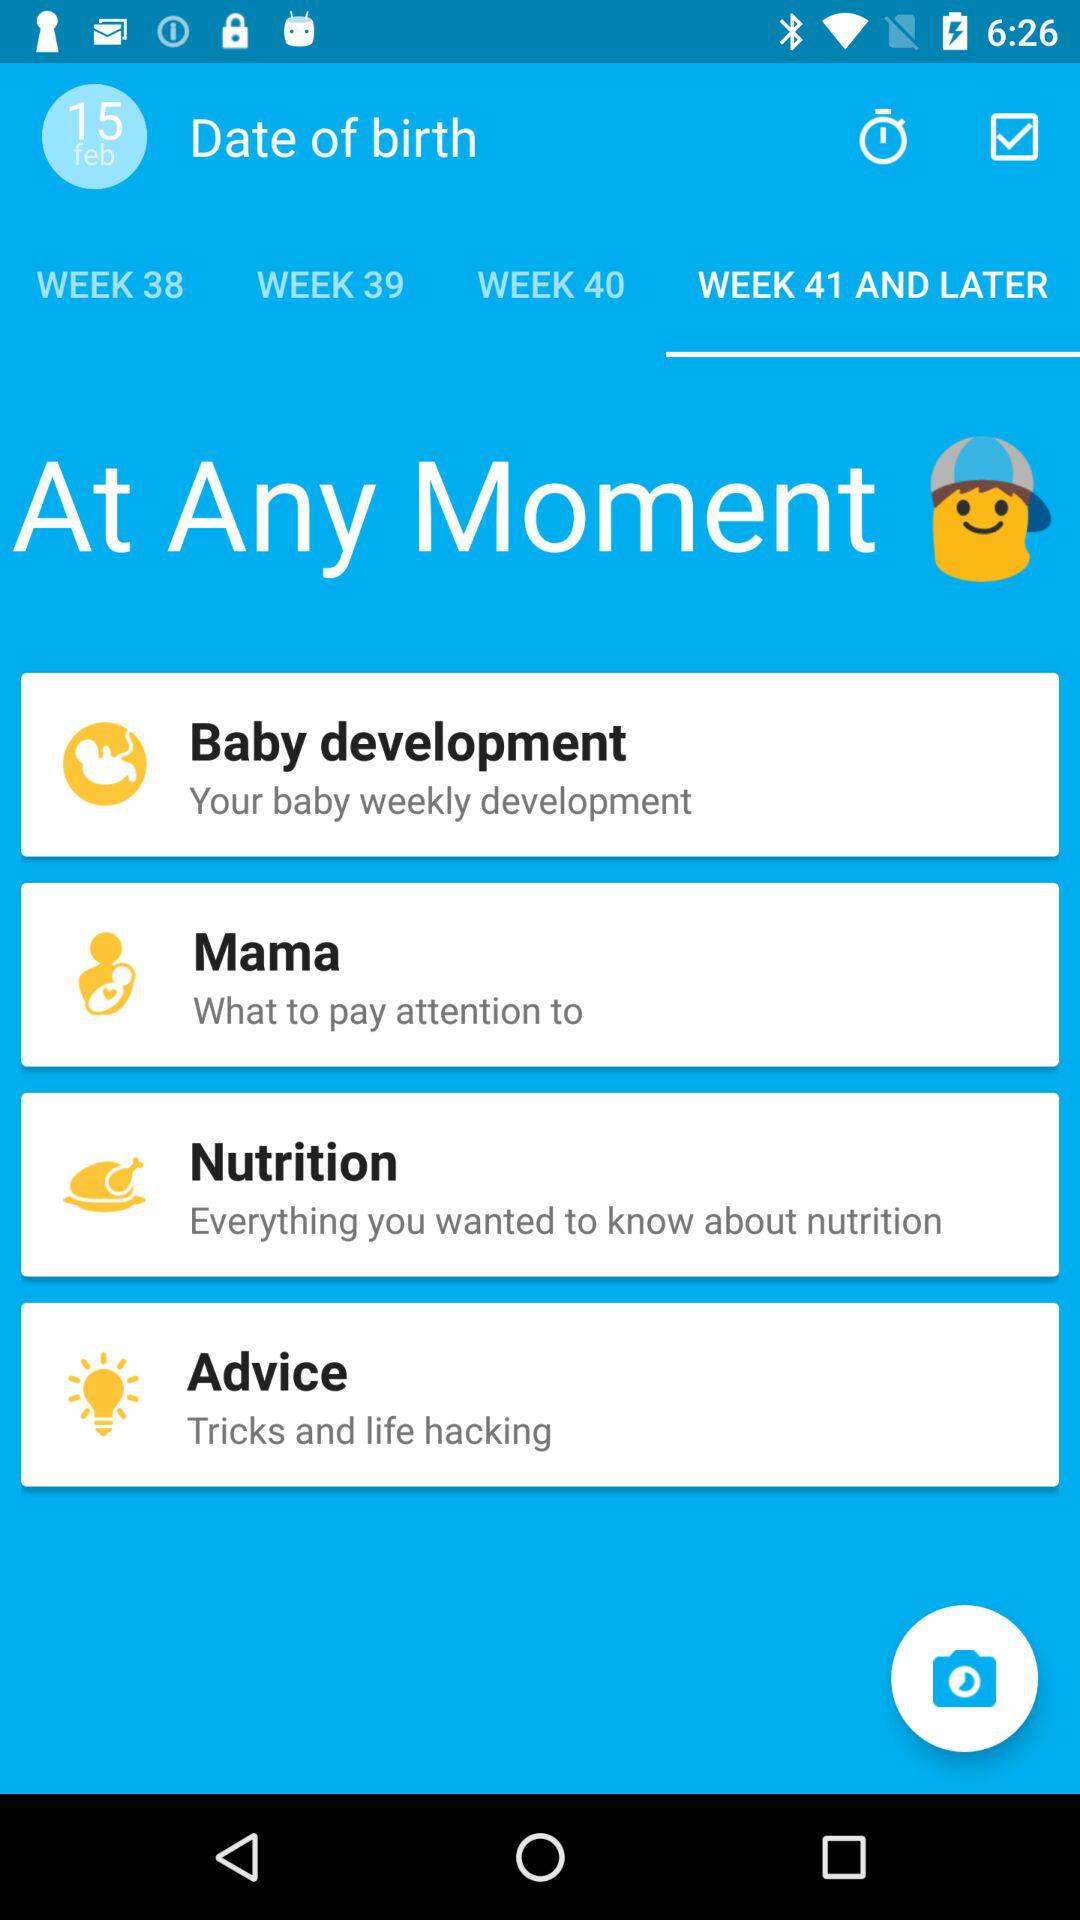What is the baby's date of birth? The date of birth is February 15. 